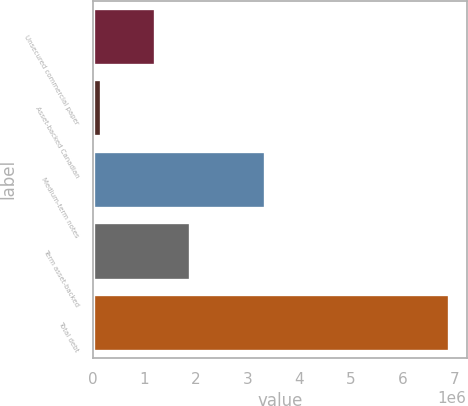<chart> <loc_0><loc_0><loc_500><loc_500><bar_chart><fcel>Unsecured commercial paper<fcel>Asset-backed Canadian<fcel>Medium-term notes<fcel>Term asset-backed<fcel>Total debt<nl><fcel>1.20138e+06<fcel>153839<fcel>3.32508e+06<fcel>1.87503e+06<fcel>6.89039e+06<nl></chart> 